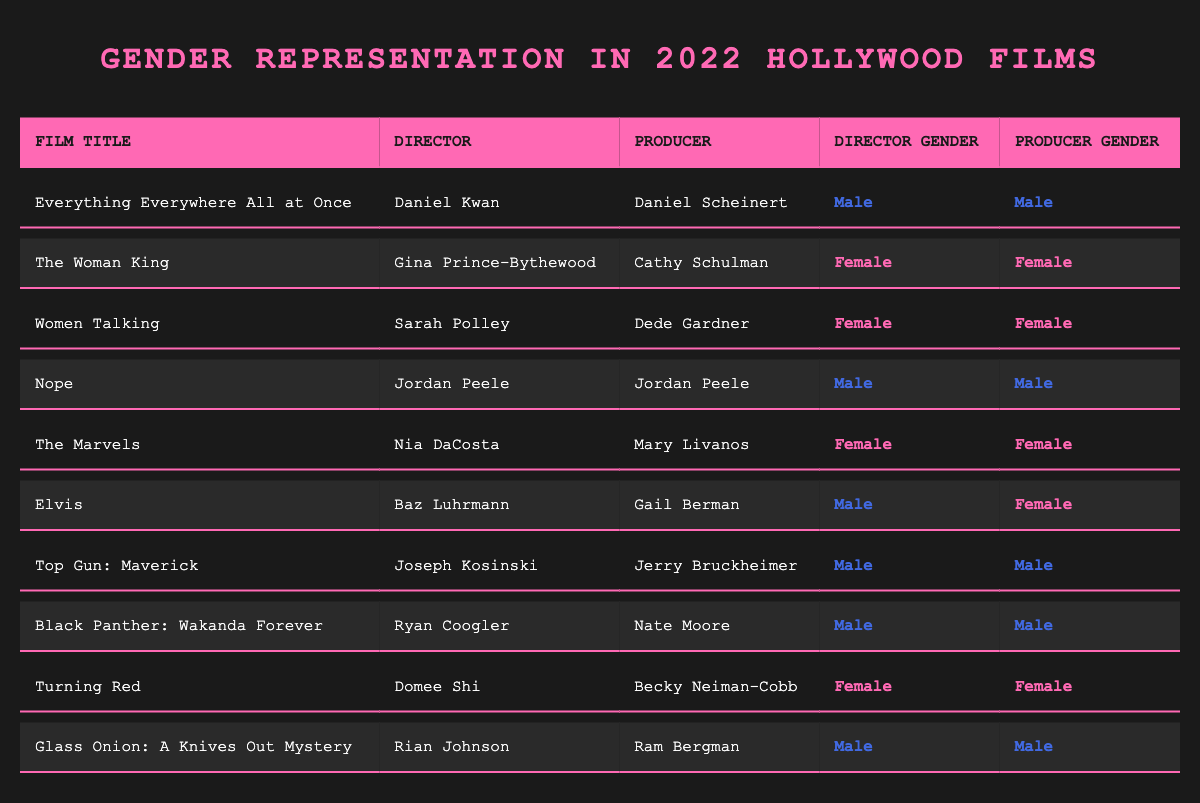What is the total number of films directed by female directors? From the table, the films directed by female directors are "The Woman King," "Women Talking," "The Marvels," and "Turning Red." There are 4 films in total.
Answer: 4 How many films have male producers? By checking the table, the films with male producers are "Everything Everywhere All at Once," "Nope," "Top Gun: Maverick," "Black Panther: Wakanda Forever," and "Glass Onion: A Knives Out Mystery." There are 5 films with male producers.
Answer: 5 Which film had both a female director and a female producer? The films "The Woman King," "Women Talking," "The Marvels," and "Turning Red" had both female directors and female producers. Thus, they share this characteristic.
Answer: "The Woman King," "Women Talking," "The Marvels," "Turning Red" What percentage of the films are directed by women? There are 10 films in total, with 4 directed by women. The percentage is (4/10) * 100 = 40%.
Answer: 40% Is it true that all films directed by women also had female producers? Looking at the table, all 4 films directed by women indeed had female producers, confirming the statement as true.
Answer: True How many films had male directors and female producers? The only film with a male director and a female producer is "Elvis." Therefore, there is 1 film fitting this criterion.
Answer: 1 What is the ratio of films directed by males to those directed by females? There are 6 films directed by males and 4 films directed by females. The ratio is 6:4, which simplifies to 3:2.
Answer: 3:2 Count the number of films where both the director and producer are male. The films where both the director and producer are male are "Everything Everywhere All at Once," "Nope," "Top Gun: Maverick," "Black Panther: Wakanda Forever," and "Glass Onion: A Knives Out Mystery." This gives us 5 films.
Answer: 5 What is the percentage of female-directed films out of the total films listed? With 4 female-directed films out of 10 total films, the percentage of female-directed films is (4/10) * 100 = 40%.
Answer: 40% 